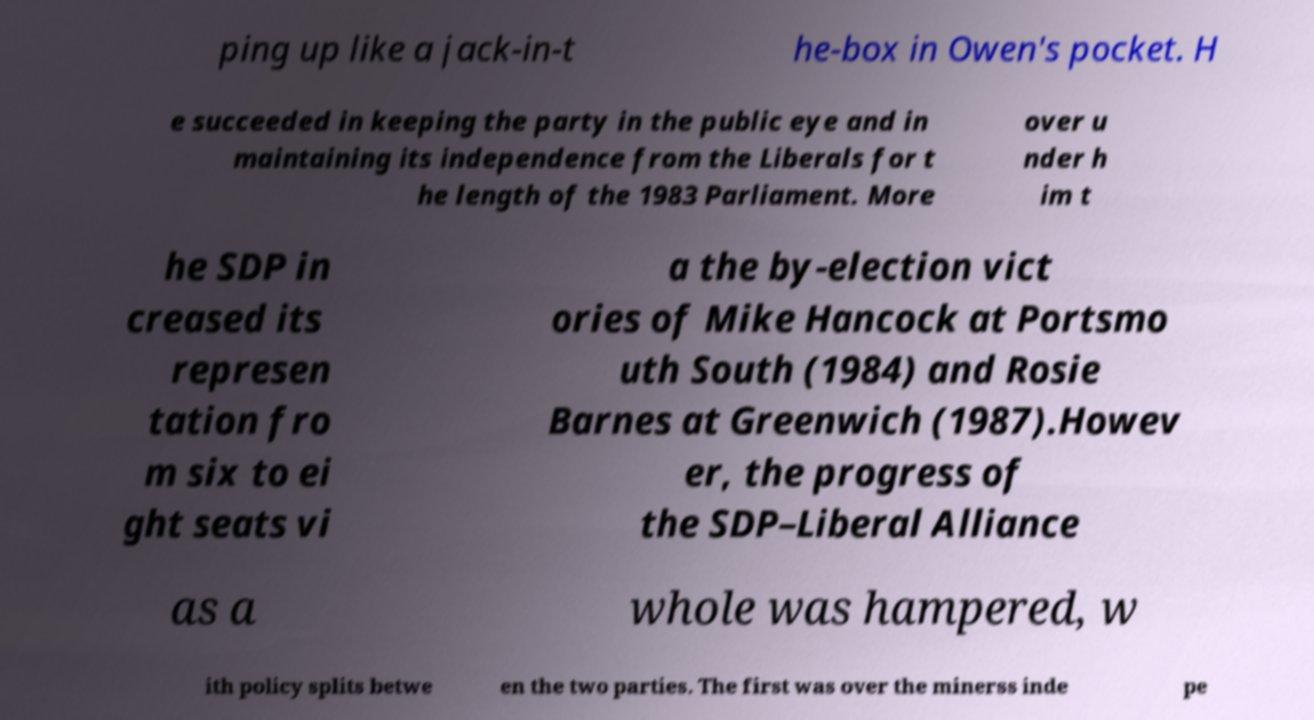I need the written content from this picture converted into text. Can you do that? ping up like a jack-in-t he-box in Owen's pocket. H e succeeded in keeping the party in the public eye and in maintaining its independence from the Liberals for t he length of the 1983 Parliament. More over u nder h im t he SDP in creased its represen tation fro m six to ei ght seats vi a the by-election vict ories of Mike Hancock at Portsmo uth South (1984) and Rosie Barnes at Greenwich (1987).Howev er, the progress of the SDP–Liberal Alliance as a whole was hampered, w ith policy splits betwe en the two parties. The first was over the minerss inde pe 